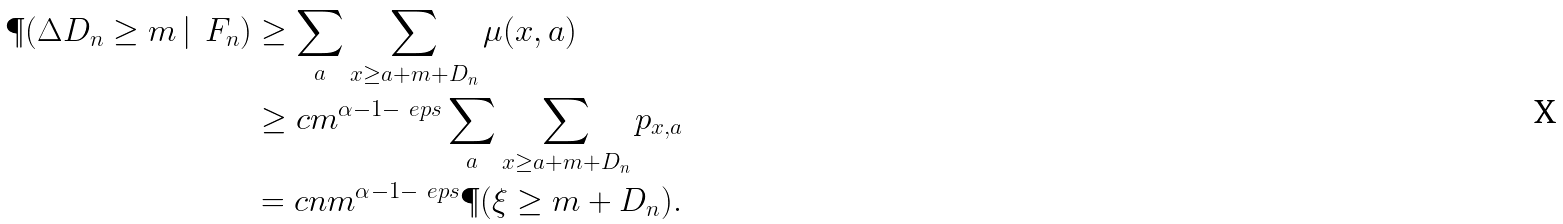Convert formula to latex. <formula><loc_0><loc_0><loc_500><loc_500>\P ( \Delta D _ { n } \geq m \, | \, \ F _ { n } ) & \geq \sum _ { a } \sum _ { x \geq a + m + D _ { n } } \mu ( x , a ) \\ & \geq c m ^ { \alpha - 1 - \ e p s } \sum _ { a } \sum _ { x \geq a + m + D _ { n } } p _ { x , a } \\ & = c n m ^ { \alpha - 1 - \ e p s } \P ( \xi \geq m + D _ { n } ) .</formula> 